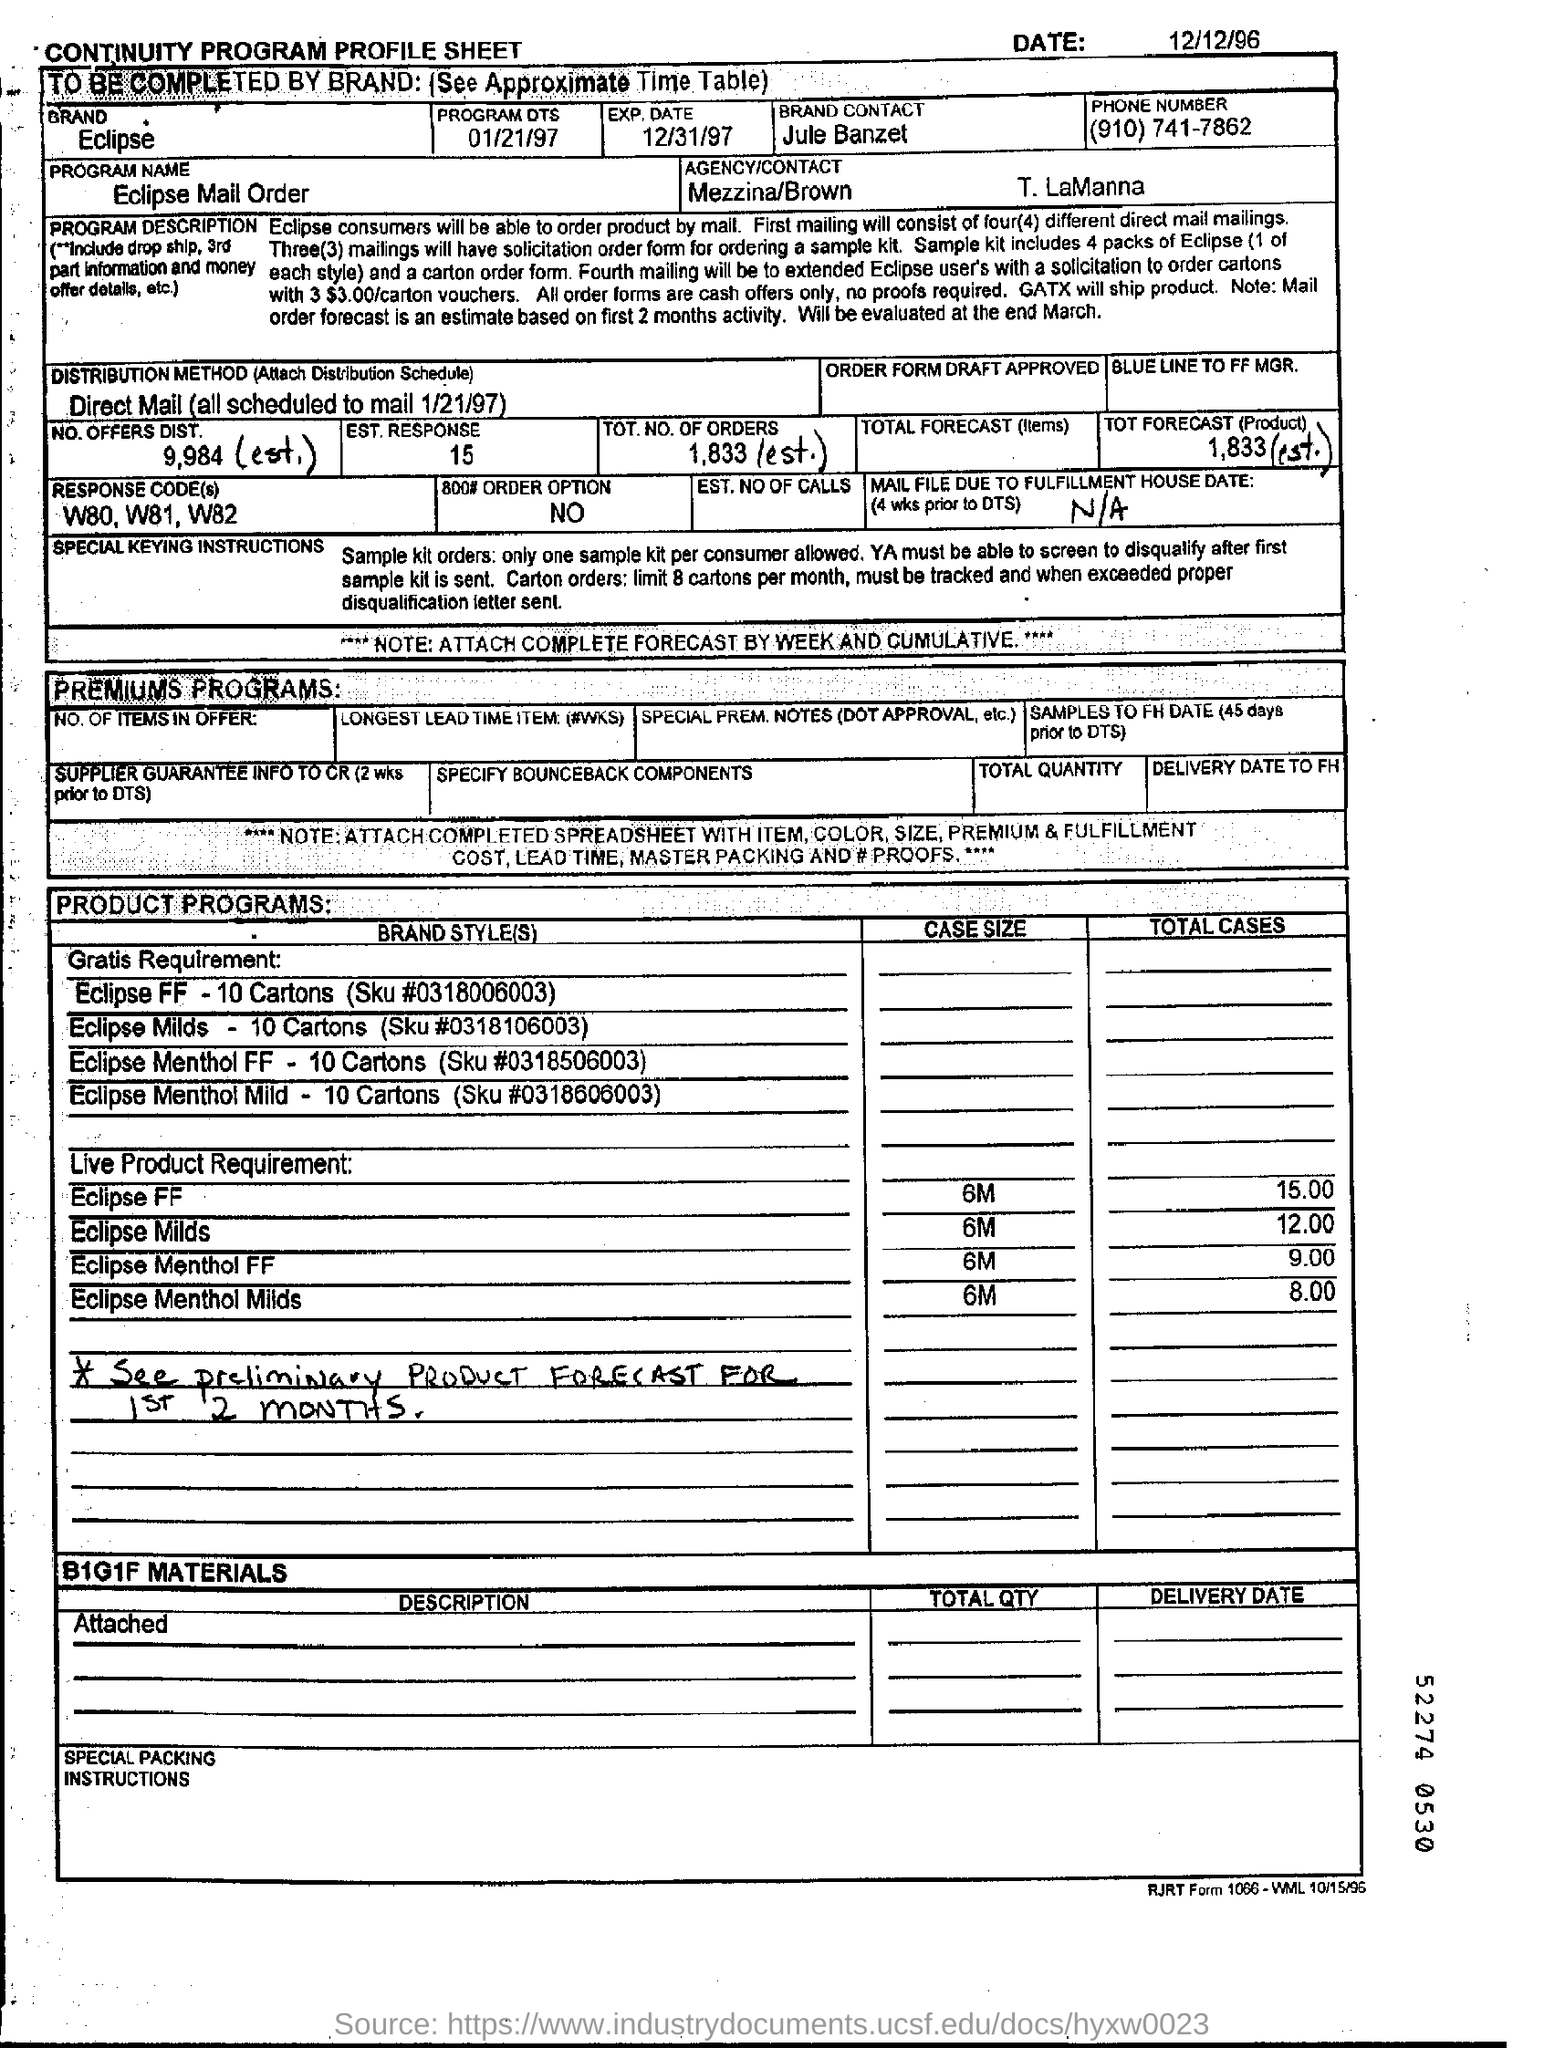Mention a couple of crucial points in this snapshot. The distribution method used is Direct Mail, which involves delivering promotional materials directly to potential customers through the postal system. 